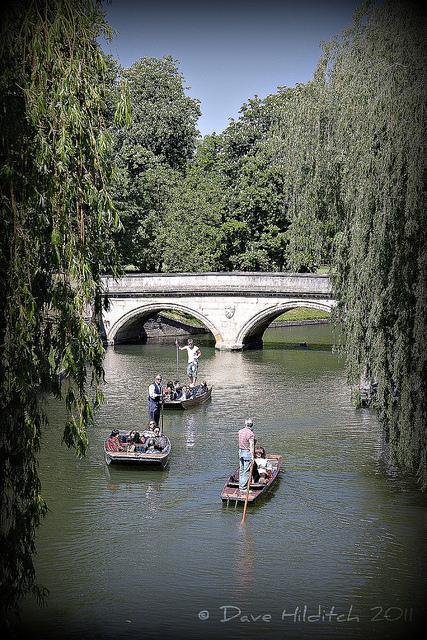Why are some people standing in the boats?
Make your selection from the four choices given to correctly answer the question.
Options: Angry, tipping boat, diving, gondoliers. Gondoliers. 